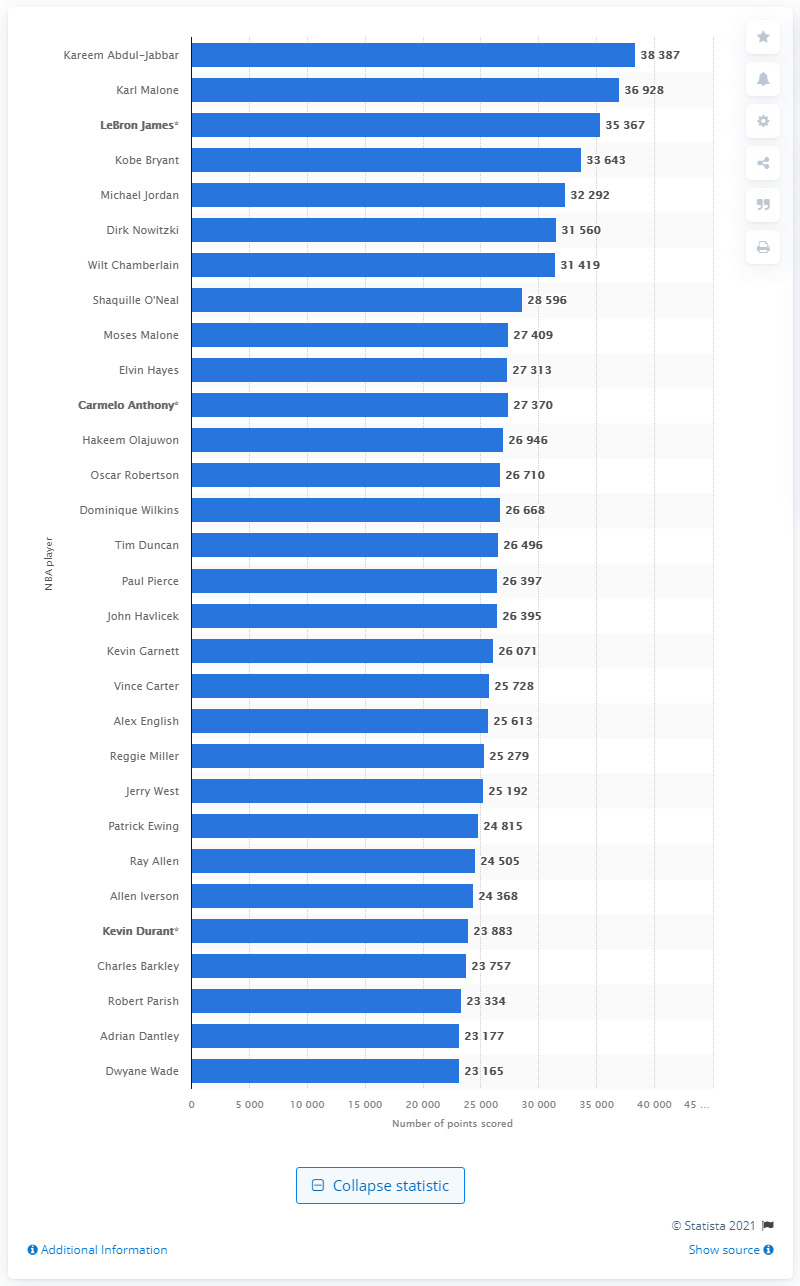Which player on this list has scored over 35,000 points but has not yet retired from professional basketball? LeBron James is the player who has surpassed 35,000 points and is still actively contributing to his scoring total in the NBA. How significant is that achievement? LeBron James reaching over 35,000 points while still playing is an extraordinary achievement. It's a testament to his longevity, consistency, and skill as one of basketball's greatest players. He is on a trajectory to potentially surpass Abdul-Jabbar as the all-time leading scorer, should he maintain his performance level. 